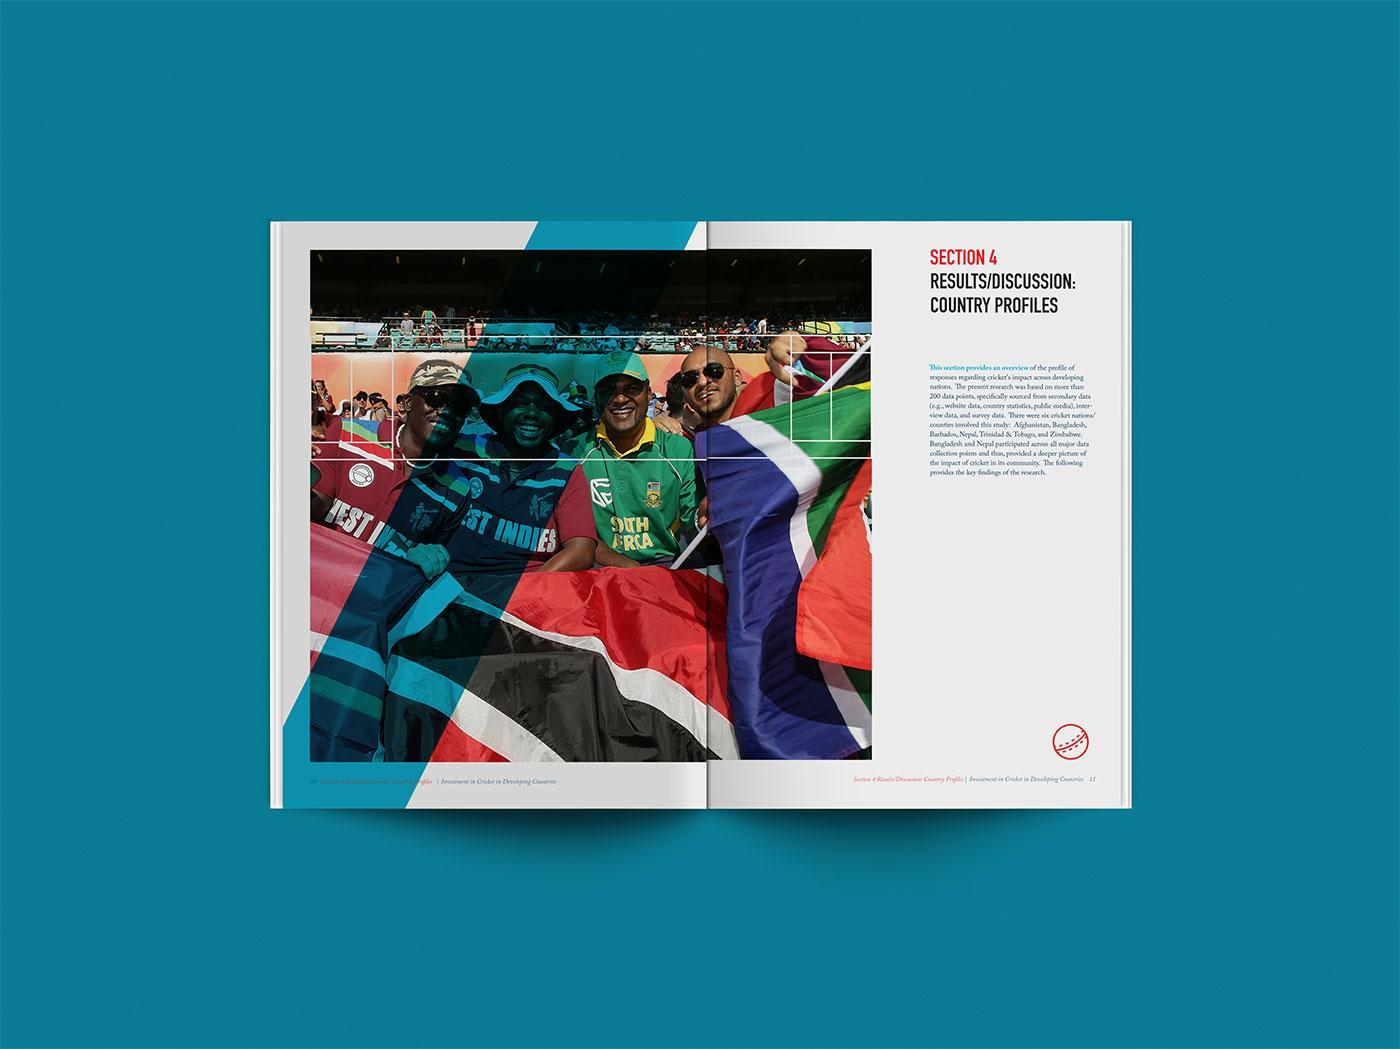Which country's names are on banyan?
Answer the question with a short phrase. West Indies, South Africa 